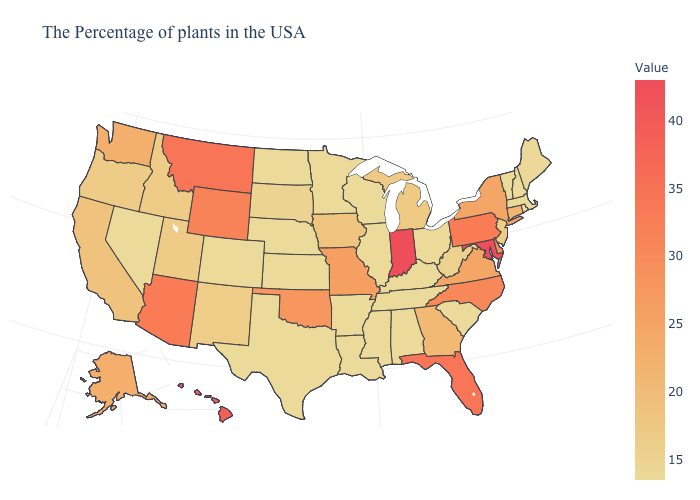Does Georgia have a lower value than Vermont?
Answer briefly. No. Among the states that border Minnesota , does North Dakota have the lowest value?
Concise answer only. Yes. Does Washington have a lower value than Missouri?
Be succinct. Yes. Among the states that border Pennsylvania , which have the highest value?
Keep it brief. Maryland. Does Hawaii have a higher value than Washington?
Quick response, please. Yes. Which states hav the highest value in the South?
Give a very brief answer. Maryland. Which states have the lowest value in the South?
Be succinct. South Carolina, Kentucky, Alabama, Tennessee, Mississippi, Louisiana, Arkansas, Texas. 